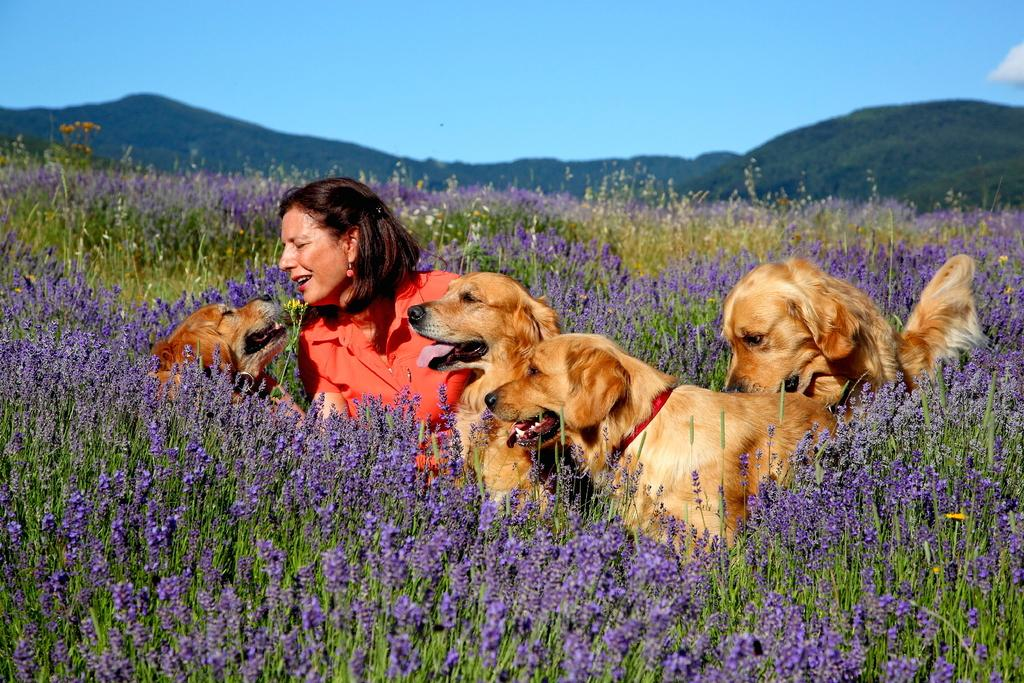Who is present in the image? There is a woman in the image. What animals are in the image? There are dogs in the image. What type of vegetation can be seen in the image? There are plants and flowers in the image. What can be seen in the background of the image? Hills and the sky are visible in the background of the image. What type of music is the band playing in the image? There is no band present in the image, so it is not possible to determine what type of music might be played. 